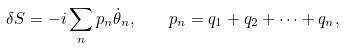<formula> <loc_0><loc_0><loc_500><loc_500>\delta S = - i \sum _ { n } p _ { n } \dot { \theta } _ { n } , \quad p _ { n } = q _ { 1 } + q _ { 2 } + \dots + q _ { n } ,</formula> 